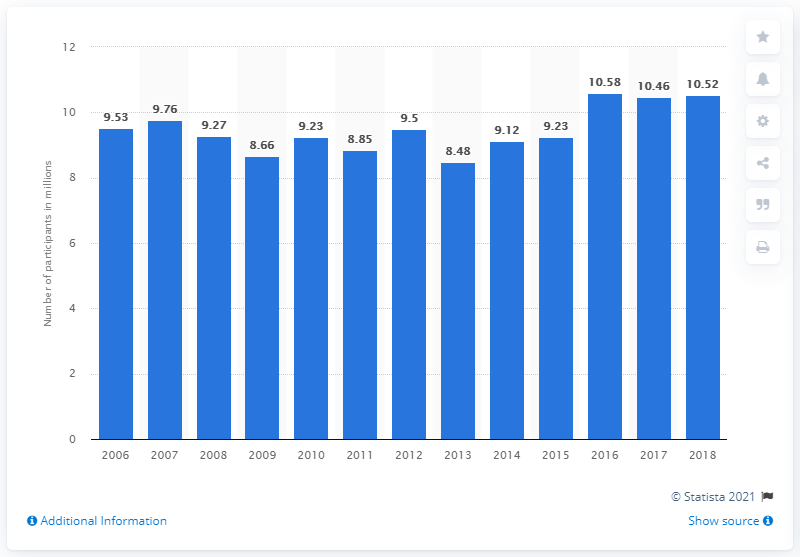Outline some significant characteristics in this image. In 2018, there were a total of 10,520 participants in aquatic exercise in the United States. 